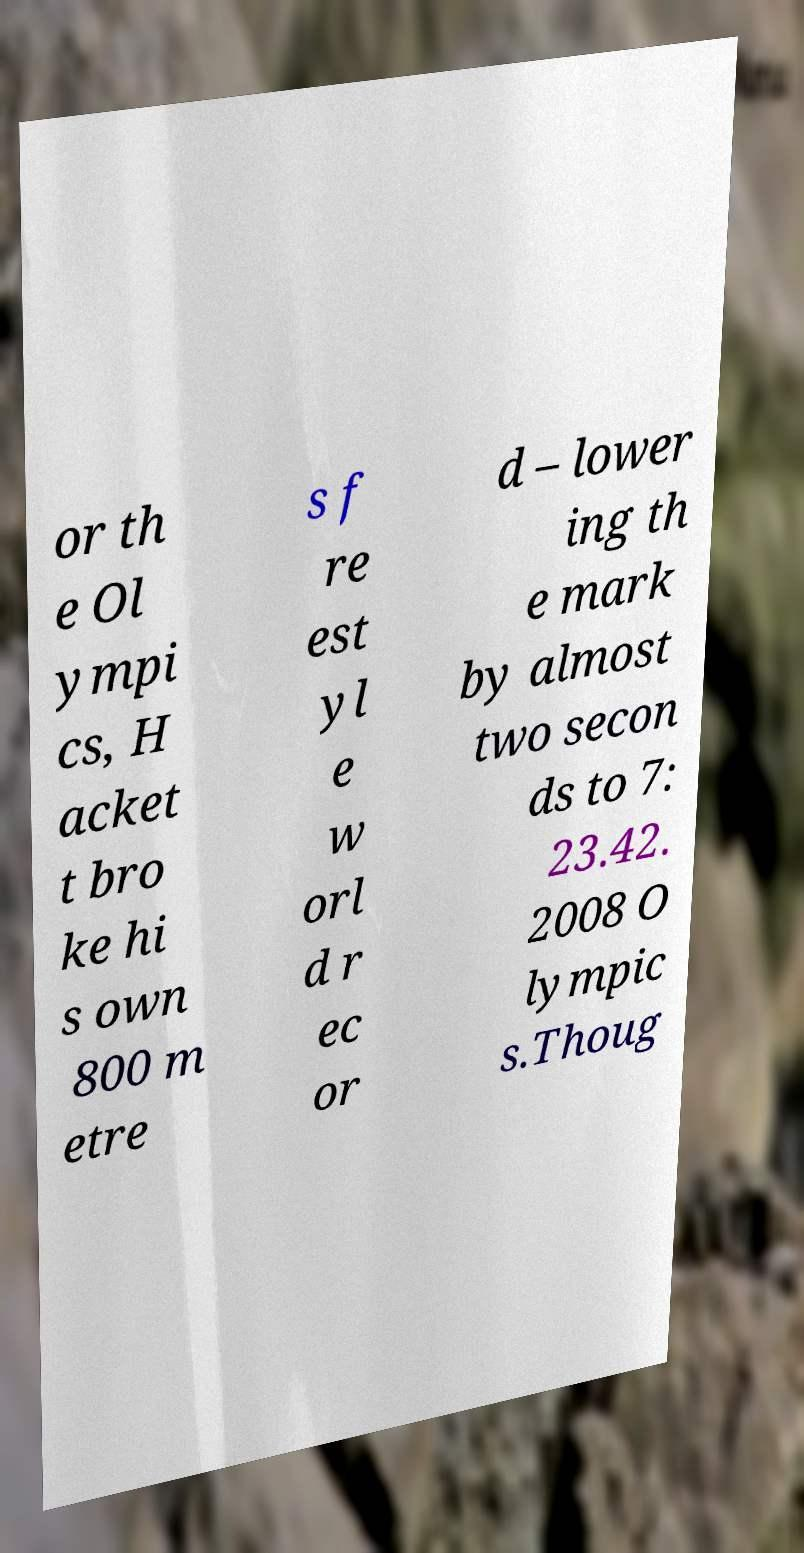I need the written content from this picture converted into text. Can you do that? or th e Ol ympi cs, H acket t bro ke hi s own 800 m etre s f re est yl e w orl d r ec or d – lower ing th e mark by almost two secon ds to 7: 23.42. 2008 O lympic s.Thoug 